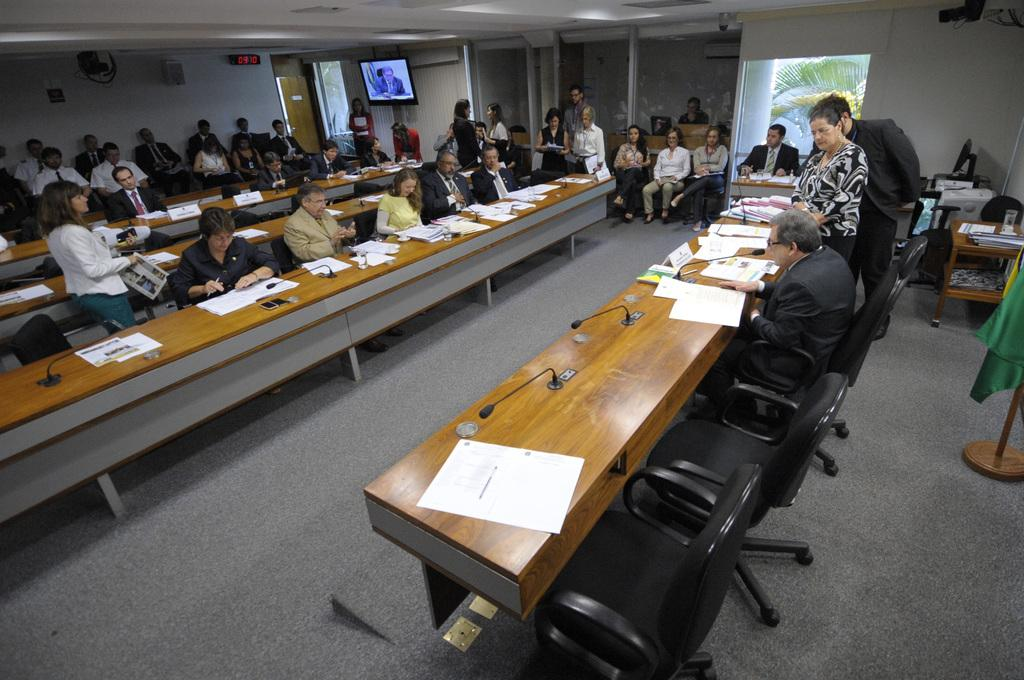What is the color of the wall in the image? The wall in the image is white. What can be found on the wall? There are doors in the image. What is present in the image that might be used for displaying information or entertainment? There is a screen in the image. What is another source of natural light in the image? There is a window in the image. What type of plant is visible in the image? There is a tree in the image. What are the people in the image doing? They are sitting on chairs in the image. What furniture is present in the image? There is a table in the image. What items can be found on the table? Papers, mics, and glasses are present on the table. How many twigs are being used as bait by the people sitting on chairs in the image? There are no twigs or bait present in the image. What type of shade is provided by the tree in the image? The image does not show any shade being provided by the tree; it only shows the tree itself. 